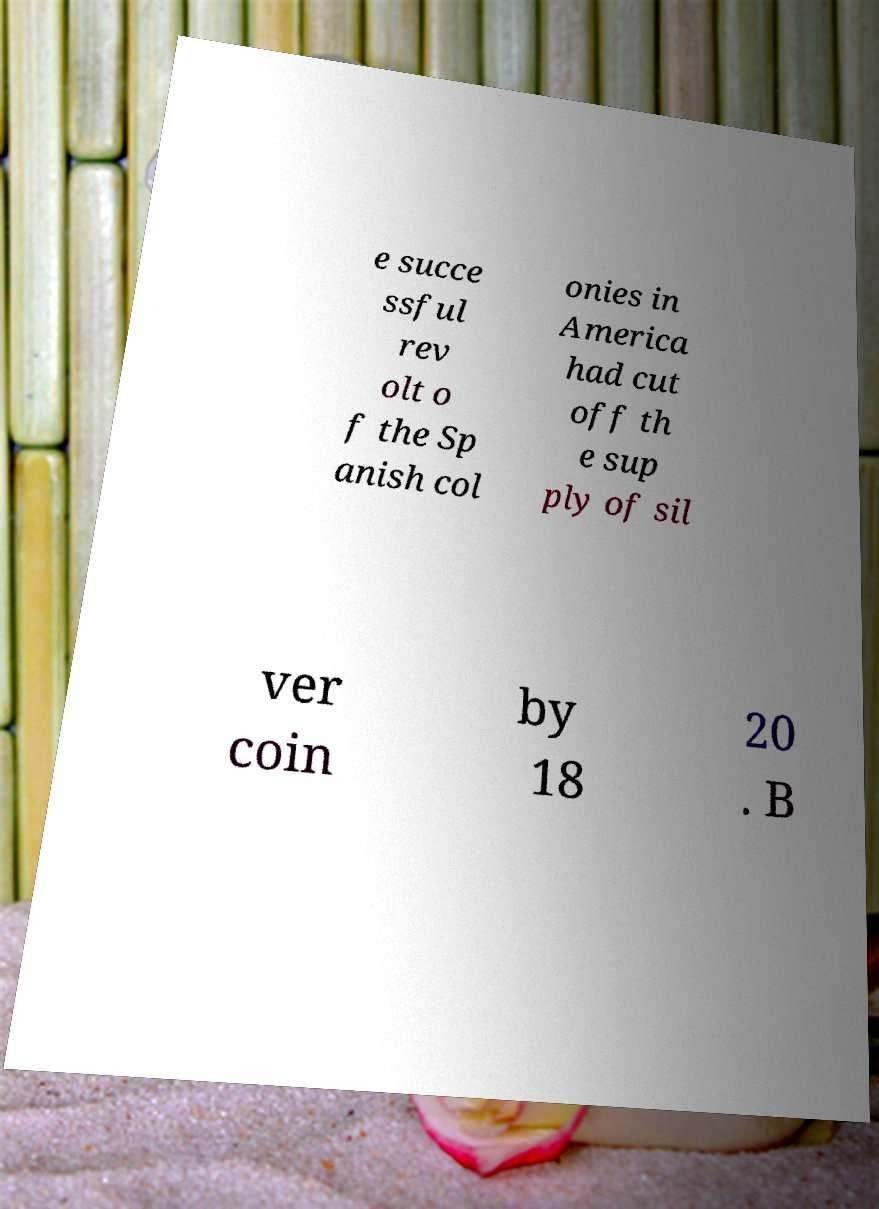What messages or text are displayed in this image? I need them in a readable, typed format. e succe ssful rev olt o f the Sp anish col onies in America had cut off th e sup ply of sil ver coin by 18 20 . B 